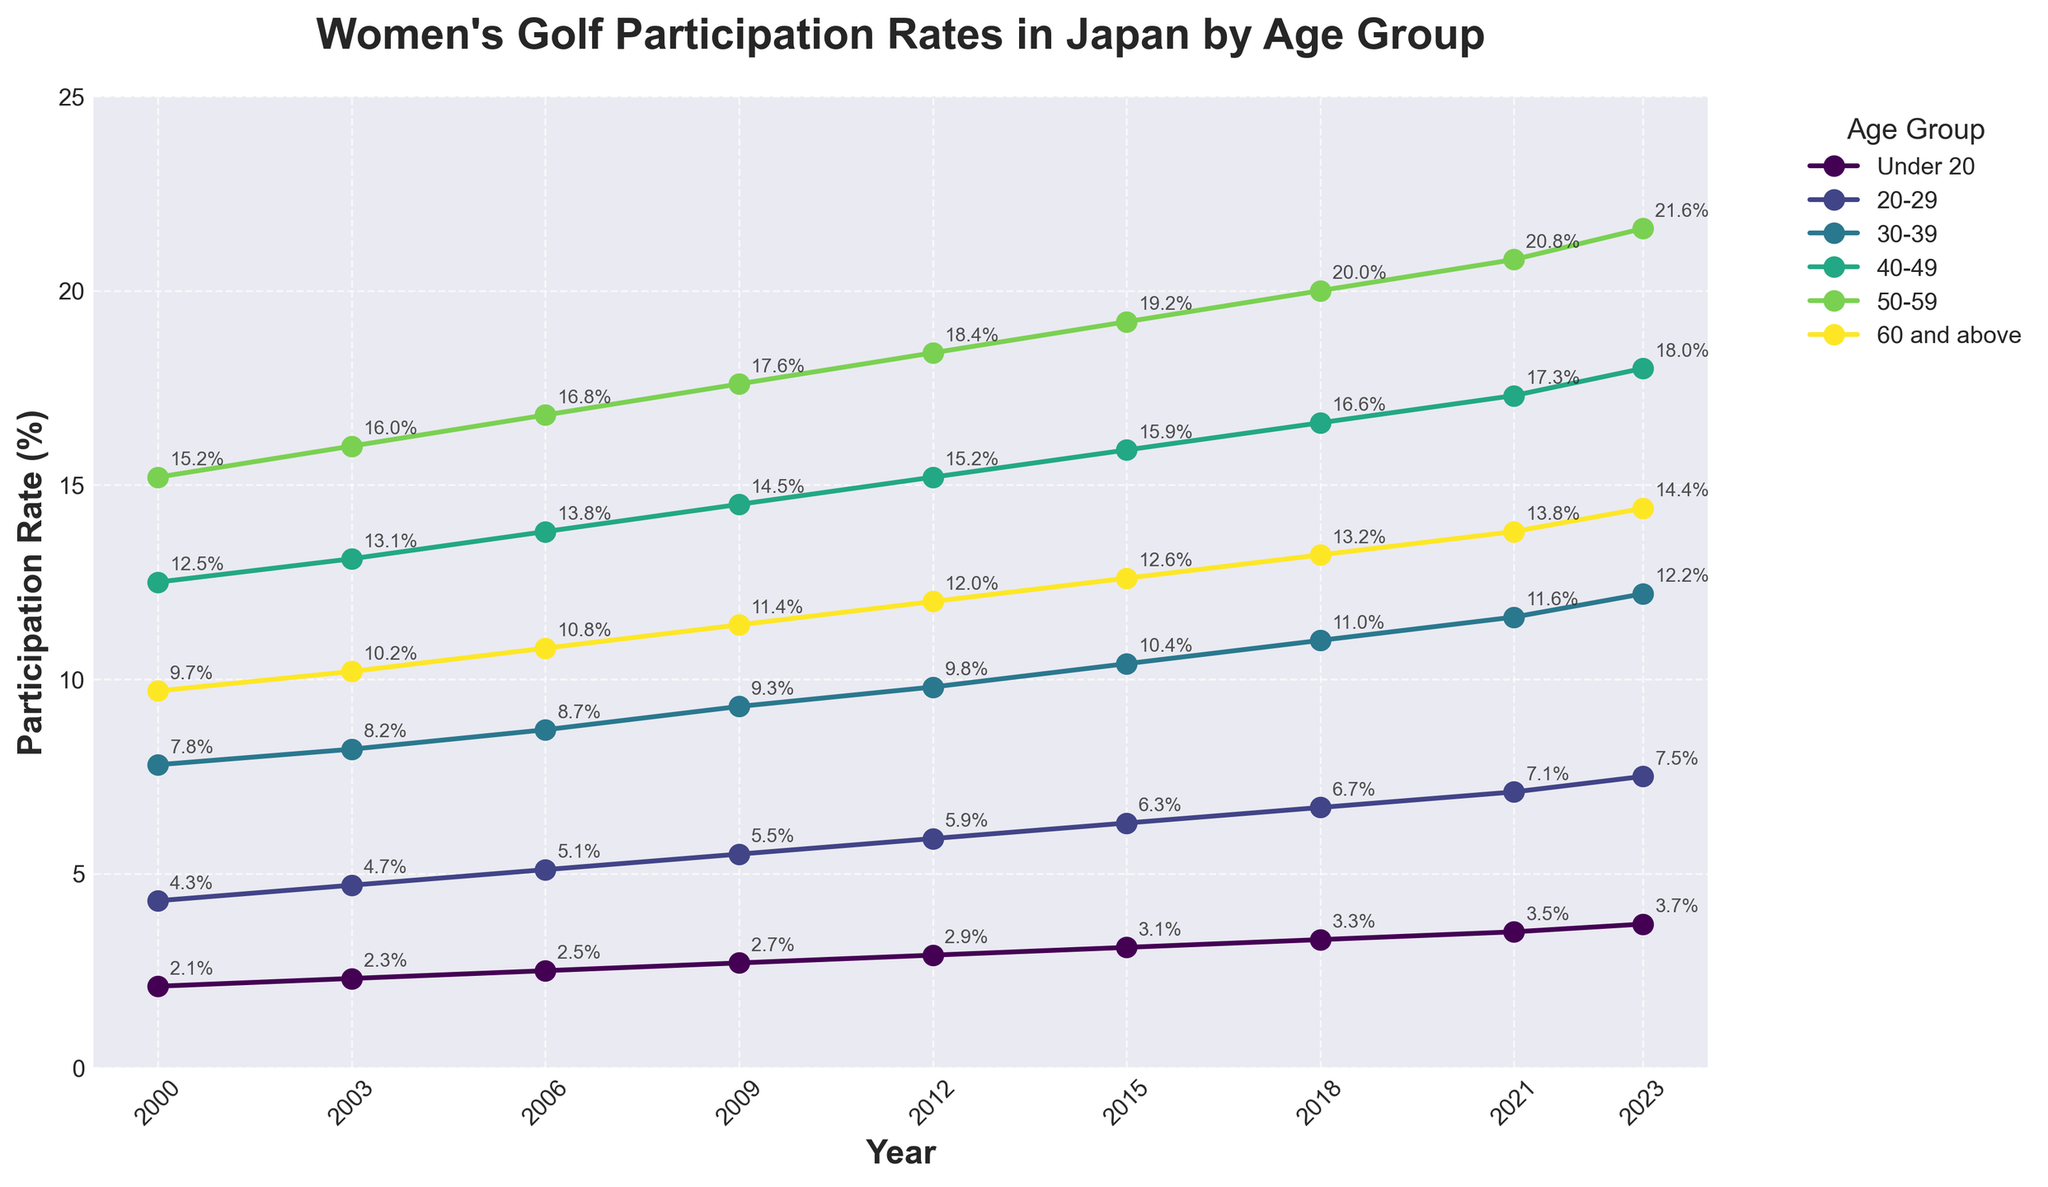What is the participation rate of the "20-29" age group in 2015? Locate the line representing the "20-29" age group, and identify the point corresponding to the year 2015. The participation rate is annotated next to the point.
Answer: 6.3% Which age group had the highest participation rate in 2023? Find the year 2023 on the x-axis and look at the heights of the lines for each age group. The "50-59" age group has the highest value.
Answer: 50-59 How did the participation rate of the "Under 20" age group change from 2000 to 2023? Look at the "Under 20" line and compare its start point in 2000 to its end point in 2023. The participation rate increased from 2.1% to 3.7%.
Answer: Increased by 1.6% What is the total participation rate in 2023 for the "30-39" and "40-49" age groups combined? Identify the participation rates for "30-39" and "40-49" in 2023, then sum them. "30-39" is 12.2% and "40-49" is 18.0%. Total is 12.2% + 18.0%.
Answer: 30.2% Which age group saw the greatest increase in participation rate from 2000 to 2023? Calculate the difference in participation rates from 2000 to 2023 for each age group and compare them. "50-59" increased from 15.2% to 21.6%, a difference of 6.4%, which is the largest increase.
Answer: 50-59 Is the participation rate trend for "60 and above" age group increasing or decreasing from 2000 to 2023? Follow the line representing the "60 and above" age group from 2000 to 2023 and observe the trend. The line is upward sloping, indicating an increasing trend.
Answer: Increasing What was the average participation rate of the "40-49" age group over the given period? Sum the participation rates of the "40-49" age group for all years and divide by the number of years. The sum is 13.3+12.5+13.1+13.8+14.5+15.2+15.9+16.6+17.3+18.0 = 147.9, divided by the 9 data points.
Answer: 16.43% By how much did the participation rate of the "50-59" age group increase from 2012 to 2023? Compare the participation rates of the "50-59" age group in 2012 and 2023. It increased from 18.4% to 21.6%. The difference is 21.6% - 18.4%.
Answer: 3.2% What is the median participation rate in 2023 across all age groups? List the 2023 rates for each age group (3.7%, 7.5%, 12.2%, 18.0%, 21.6%, 14.4%) and find the middle value(s). The median is the average of the 3rd and 4th values in the sorted list (12.2% and 14.4%).
Answer: 15.3% 